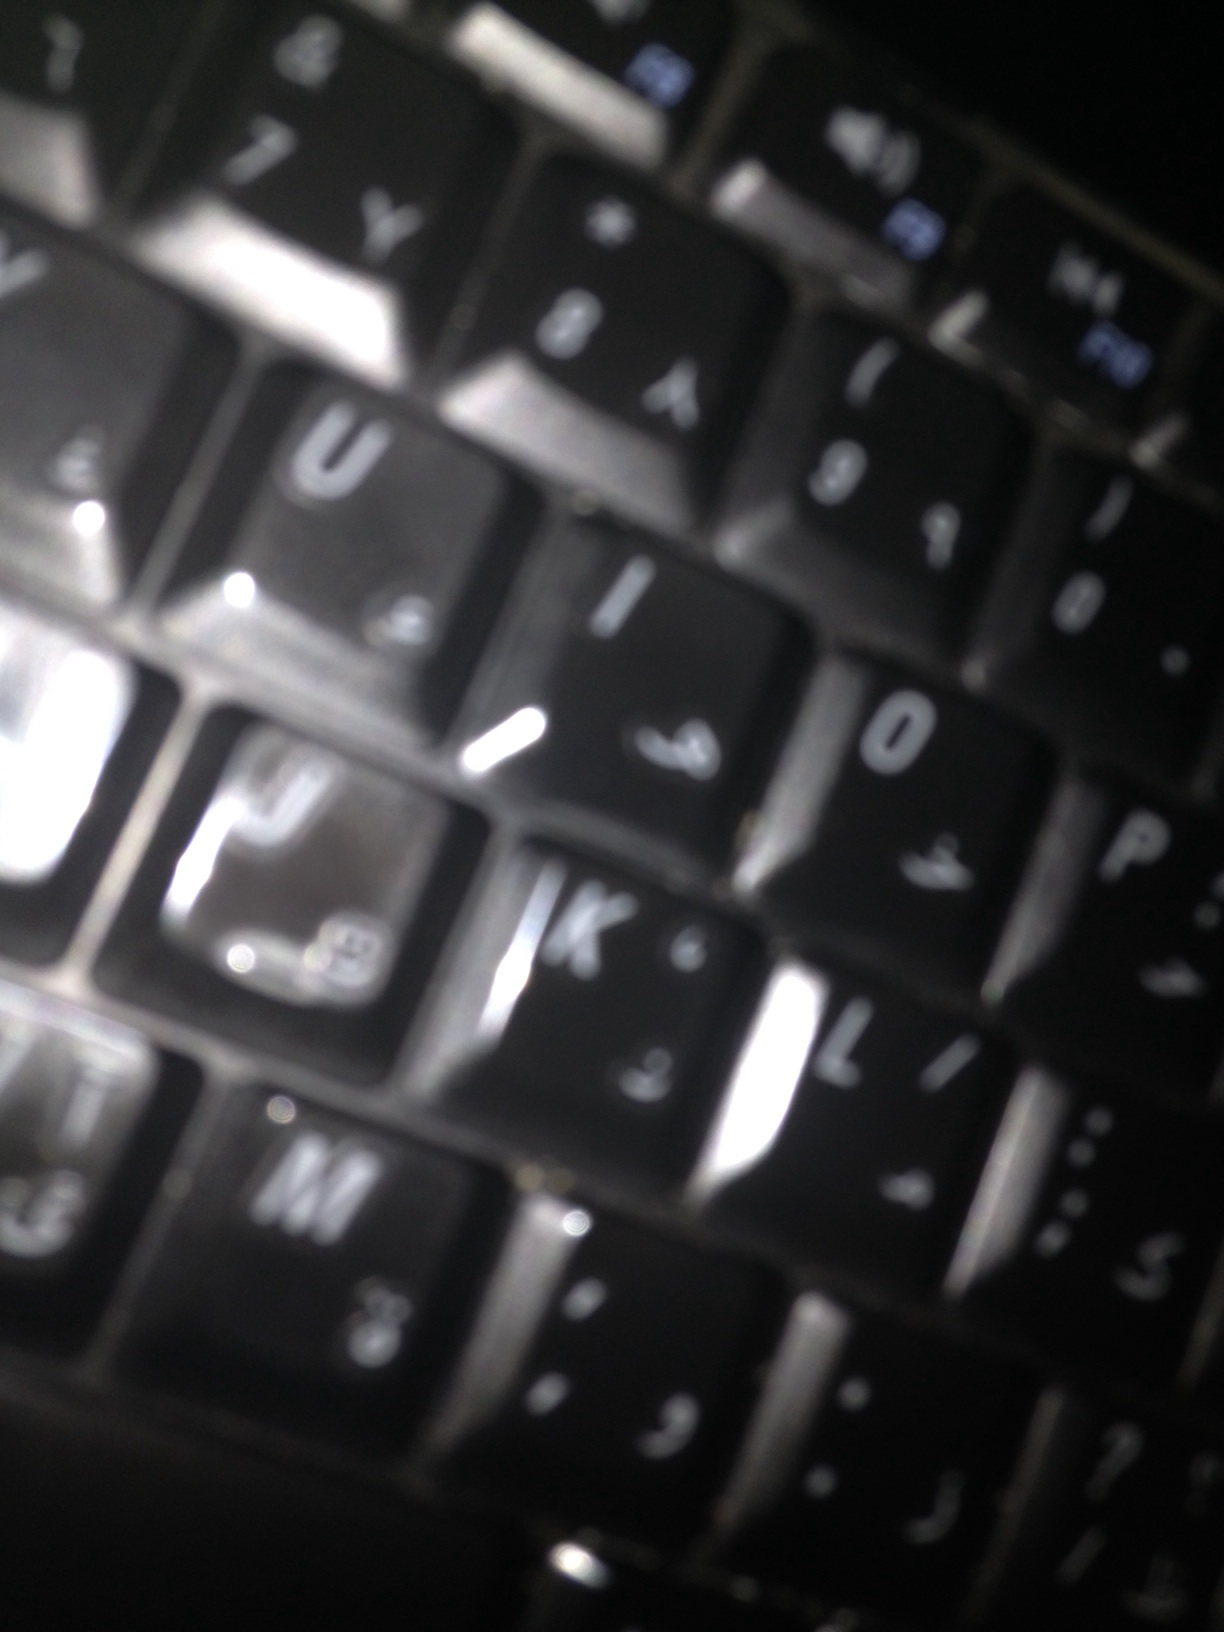If you could add any feature to this keyboard, what would it be? If I could add a feature to this keyboard, I would integrate backlighting that can change colors based on different time zones or moods. This would not only add a visually appealing element but also help indicate the time of day or serve as a gentle reminder to take breaks. 